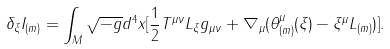<formula> <loc_0><loc_0><loc_500><loc_500>\delta _ { \xi } I _ { ( m ) } = \int _ { M } \sqrt { - g } d ^ { 4 } x [ \frac { 1 } { 2 } T ^ { \mu \nu } L _ { \xi } g _ { \mu \nu } + \nabla _ { \mu } ( \theta _ { ( m ) } ^ { \mu } ( \xi ) - \xi ^ { \mu } L _ { ( m ) } ) ] .</formula> 